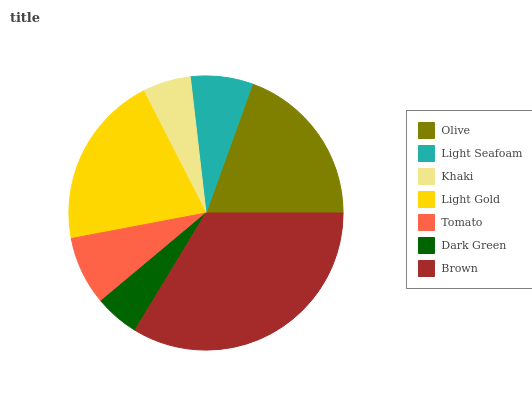Is Dark Green the minimum?
Answer yes or no. Yes. Is Brown the maximum?
Answer yes or no. Yes. Is Light Seafoam the minimum?
Answer yes or no. No. Is Light Seafoam the maximum?
Answer yes or no. No. Is Olive greater than Light Seafoam?
Answer yes or no. Yes. Is Light Seafoam less than Olive?
Answer yes or no. Yes. Is Light Seafoam greater than Olive?
Answer yes or no. No. Is Olive less than Light Seafoam?
Answer yes or no. No. Is Tomato the high median?
Answer yes or no. Yes. Is Tomato the low median?
Answer yes or no. Yes. Is Brown the high median?
Answer yes or no. No. Is Brown the low median?
Answer yes or no. No. 